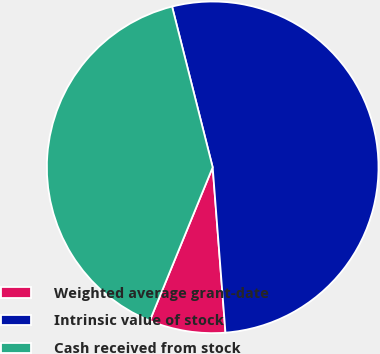Convert chart to OTSL. <chart><loc_0><loc_0><loc_500><loc_500><pie_chart><fcel>Weighted average grant-date<fcel>Intrinsic value of stock<fcel>Cash received from stock<nl><fcel>7.42%<fcel>52.71%<fcel>39.87%<nl></chart> 